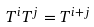Convert formula to latex. <formula><loc_0><loc_0><loc_500><loc_500>T ^ { i } T ^ { j } = T ^ { i + j }</formula> 